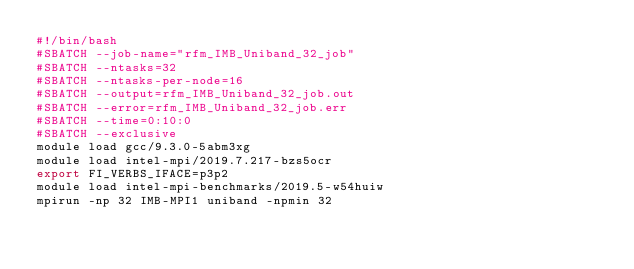<code> <loc_0><loc_0><loc_500><loc_500><_Bash_>#!/bin/bash
#SBATCH --job-name="rfm_IMB_Uniband_32_job"
#SBATCH --ntasks=32
#SBATCH --ntasks-per-node=16
#SBATCH --output=rfm_IMB_Uniband_32_job.out
#SBATCH --error=rfm_IMB_Uniband_32_job.err
#SBATCH --time=0:10:0
#SBATCH --exclusive
module load gcc/9.3.0-5abm3xg
module load intel-mpi/2019.7.217-bzs5ocr
export FI_VERBS_IFACE=p3p2
module load intel-mpi-benchmarks/2019.5-w54huiw
mpirun -np 32 IMB-MPI1 uniband -npmin 32
</code> 